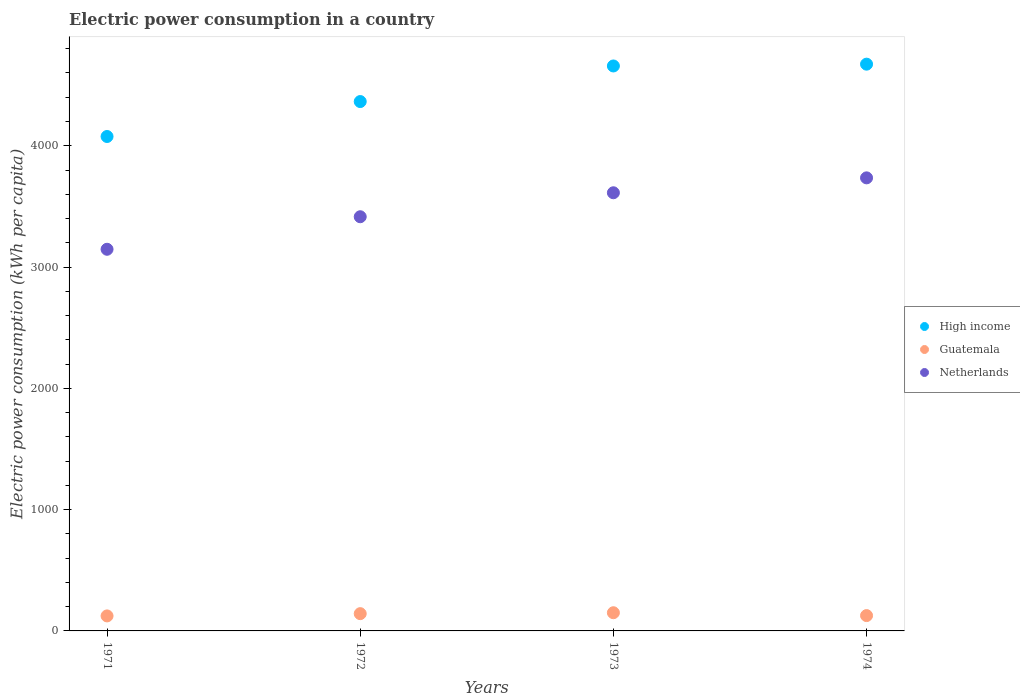How many different coloured dotlines are there?
Offer a very short reply. 3. Is the number of dotlines equal to the number of legend labels?
Provide a short and direct response. Yes. What is the electric power consumption in in Guatemala in 1973?
Keep it short and to the point. 149.95. Across all years, what is the maximum electric power consumption in in Netherlands?
Make the answer very short. 3735.24. Across all years, what is the minimum electric power consumption in in High income?
Keep it short and to the point. 4076.2. In which year was the electric power consumption in in High income maximum?
Your response must be concise. 1974. In which year was the electric power consumption in in High income minimum?
Make the answer very short. 1971. What is the total electric power consumption in in Guatemala in the graph?
Provide a succinct answer. 542.42. What is the difference between the electric power consumption in in Netherlands in 1972 and that in 1974?
Give a very brief answer. -320.55. What is the difference between the electric power consumption in in Guatemala in 1971 and the electric power consumption in in Netherlands in 1974?
Ensure brevity in your answer.  -3611.53. What is the average electric power consumption in in High income per year?
Provide a short and direct response. 4442.7. In the year 1974, what is the difference between the electric power consumption in in Guatemala and electric power consumption in in High income?
Make the answer very short. -4546.2. What is the ratio of the electric power consumption in in Netherlands in 1972 to that in 1974?
Offer a terse response. 0.91. What is the difference between the highest and the second highest electric power consumption in in Guatemala?
Your answer should be compact. 7.56. What is the difference between the highest and the lowest electric power consumption in in Guatemala?
Ensure brevity in your answer.  26.25. Is the sum of the electric power consumption in in Guatemala in 1971 and 1972 greater than the maximum electric power consumption in in Netherlands across all years?
Provide a succinct answer. No. Is it the case that in every year, the sum of the electric power consumption in in Netherlands and electric power consumption in in Guatemala  is greater than the electric power consumption in in High income?
Your answer should be compact. No. Does the electric power consumption in in High income monotonically increase over the years?
Provide a succinct answer. Yes. Is the electric power consumption in in Netherlands strictly greater than the electric power consumption in in High income over the years?
Provide a succinct answer. No. Is the electric power consumption in in Netherlands strictly less than the electric power consumption in in High income over the years?
Your answer should be very brief. Yes. What is the difference between two consecutive major ticks on the Y-axis?
Make the answer very short. 1000. Are the values on the major ticks of Y-axis written in scientific E-notation?
Ensure brevity in your answer.  No. Does the graph contain any zero values?
Ensure brevity in your answer.  No. Does the graph contain grids?
Make the answer very short. No. Where does the legend appear in the graph?
Offer a very short reply. Center right. How are the legend labels stacked?
Offer a terse response. Vertical. What is the title of the graph?
Make the answer very short. Electric power consumption in a country. Does "Cabo Verde" appear as one of the legend labels in the graph?
Provide a short and direct response. No. What is the label or title of the Y-axis?
Provide a succinct answer. Electric power consumption (kWh per capita). What is the Electric power consumption (kWh per capita) in High income in 1971?
Keep it short and to the point. 4076.2. What is the Electric power consumption (kWh per capita) of Guatemala in 1971?
Ensure brevity in your answer.  123.7. What is the Electric power consumption (kWh per capita) in Netherlands in 1971?
Offer a terse response. 3146.46. What is the Electric power consumption (kWh per capita) of High income in 1972?
Provide a short and direct response. 4364.31. What is the Electric power consumption (kWh per capita) of Guatemala in 1972?
Your answer should be very brief. 142.39. What is the Electric power consumption (kWh per capita) in Netherlands in 1972?
Offer a terse response. 3414.69. What is the Electric power consumption (kWh per capita) in High income in 1973?
Offer a terse response. 4657.71. What is the Electric power consumption (kWh per capita) of Guatemala in 1973?
Provide a short and direct response. 149.95. What is the Electric power consumption (kWh per capita) of Netherlands in 1973?
Give a very brief answer. 3612.31. What is the Electric power consumption (kWh per capita) of High income in 1974?
Keep it short and to the point. 4672.57. What is the Electric power consumption (kWh per capita) of Guatemala in 1974?
Keep it short and to the point. 126.38. What is the Electric power consumption (kWh per capita) in Netherlands in 1974?
Give a very brief answer. 3735.24. Across all years, what is the maximum Electric power consumption (kWh per capita) in High income?
Make the answer very short. 4672.57. Across all years, what is the maximum Electric power consumption (kWh per capita) of Guatemala?
Ensure brevity in your answer.  149.95. Across all years, what is the maximum Electric power consumption (kWh per capita) of Netherlands?
Ensure brevity in your answer.  3735.24. Across all years, what is the minimum Electric power consumption (kWh per capita) of High income?
Ensure brevity in your answer.  4076.2. Across all years, what is the minimum Electric power consumption (kWh per capita) in Guatemala?
Give a very brief answer. 123.7. Across all years, what is the minimum Electric power consumption (kWh per capita) of Netherlands?
Give a very brief answer. 3146.46. What is the total Electric power consumption (kWh per capita) of High income in the graph?
Provide a succinct answer. 1.78e+04. What is the total Electric power consumption (kWh per capita) in Guatemala in the graph?
Your answer should be very brief. 542.42. What is the total Electric power consumption (kWh per capita) in Netherlands in the graph?
Your answer should be very brief. 1.39e+04. What is the difference between the Electric power consumption (kWh per capita) of High income in 1971 and that in 1972?
Offer a terse response. -288.11. What is the difference between the Electric power consumption (kWh per capita) of Guatemala in 1971 and that in 1972?
Provide a short and direct response. -18.69. What is the difference between the Electric power consumption (kWh per capita) of Netherlands in 1971 and that in 1972?
Your response must be concise. -268.23. What is the difference between the Electric power consumption (kWh per capita) in High income in 1971 and that in 1973?
Provide a succinct answer. -581.5. What is the difference between the Electric power consumption (kWh per capita) of Guatemala in 1971 and that in 1973?
Ensure brevity in your answer.  -26.25. What is the difference between the Electric power consumption (kWh per capita) in Netherlands in 1971 and that in 1973?
Your response must be concise. -465.85. What is the difference between the Electric power consumption (kWh per capita) of High income in 1971 and that in 1974?
Provide a succinct answer. -596.37. What is the difference between the Electric power consumption (kWh per capita) of Guatemala in 1971 and that in 1974?
Provide a short and direct response. -2.67. What is the difference between the Electric power consumption (kWh per capita) of Netherlands in 1971 and that in 1974?
Provide a short and direct response. -588.77. What is the difference between the Electric power consumption (kWh per capita) of High income in 1972 and that in 1973?
Your response must be concise. -293.4. What is the difference between the Electric power consumption (kWh per capita) of Guatemala in 1972 and that in 1973?
Your response must be concise. -7.56. What is the difference between the Electric power consumption (kWh per capita) of Netherlands in 1972 and that in 1973?
Keep it short and to the point. -197.62. What is the difference between the Electric power consumption (kWh per capita) in High income in 1972 and that in 1974?
Provide a short and direct response. -308.27. What is the difference between the Electric power consumption (kWh per capita) of Guatemala in 1972 and that in 1974?
Offer a terse response. 16.01. What is the difference between the Electric power consumption (kWh per capita) of Netherlands in 1972 and that in 1974?
Keep it short and to the point. -320.55. What is the difference between the Electric power consumption (kWh per capita) of High income in 1973 and that in 1974?
Make the answer very short. -14.87. What is the difference between the Electric power consumption (kWh per capita) in Guatemala in 1973 and that in 1974?
Your response must be concise. 23.57. What is the difference between the Electric power consumption (kWh per capita) of Netherlands in 1973 and that in 1974?
Make the answer very short. -122.93. What is the difference between the Electric power consumption (kWh per capita) in High income in 1971 and the Electric power consumption (kWh per capita) in Guatemala in 1972?
Provide a succinct answer. 3933.81. What is the difference between the Electric power consumption (kWh per capita) of High income in 1971 and the Electric power consumption (kWh per capita) of Netherlands in 1972?
Keep it short and to the point. 661.51. What is the difference between the Electric power consumption (kWh per capita) in Guatemala in 1971 and the Electric power consumption (kWh per capita) in Netherlands in 1972?
Offer a very short reply. -3290.98. What is the difference between the Electric power consumption (kWh per capita) in High income in 1971 and the Electric power consumption (kWh per capita) in Guatemala in 1973?
Provide a short and direct response. 3926.25. What is the difference between the Electric power consumption (kWh per capita) in High income in 1971 and the Electric power consumption (kWh per capita) in Netherlands in 1973?
Keep it short and to the point. 463.89. What is the difference between the Electric power consumption (kWh per capita) of Guatemala in 1971 and the Electric power consumption (kWh per capita) of Netherlands in 1973?
Provide a short and direct response. -3488.61. What is the difference between the Electric power consumption (kWh per capita) in High income in 1971 and the Electric power consumption (kWh per capita) in Guatemala in 1974?
Your response must be concise. 3949.82. What is the difference between the Electric power consumption (kWh per capita) in High income in 1971 and the Electric power consumption (kWh per capita) in Netherlands in 1974?
Your answer should be very brief. 340.96. What is the difference between the Electric power consumption (kWh per capita) in Guatemala in 1971 and the Electric power consumption (kWh per capita) in Netherlands in 1974?
Your answer should be compact. -3611.53. What is the difference between the Electric power consumption (kWh per capita) in High income in 1972 and the Electric power consumption (kWh per capita) in Guatemala in 1973?
Provide a short and direct response. 4214.36. What is the difference between the Electric power consumption (kWh per capita) in High income in 1972 and the Electric power consumption (kWh per capita) in Netherlands in 1973?
Give a very brief answer. 752. What is the difference between the Electric power consumption (kWh per capita) in Guatemala in 1972 and the Electric power consumption (kWh per capita) in Netherlands in 1973?
Ensure brevity in your answer.  -3469.92. What is the difference between the Electric power consumption (kWh per capita) of High income in 1972 and the Electric power consumption (kWh per capita) of Guatemala in 1974?
Provide a short and direct response. 4237.93. What is the difference between the Electric power consumption (kWh per capita) in High income in 1972 and the Electric power consumption (kWh per capita) in Netherlands in 1974?
Provide a succinct answer. 629.07. What is the difference between the Electric power consumption (kWh per capita) in Guatemala in 1972 and the Electric power consumption (kWh per capita) in Netherlands in 1974?
Ensure brevity in your answer.  -3592.85. What is the difference between the Electric power consumption (kWh per capita) of High income in 1973 and the Electric power consumption (kWh per capita) of Guatemala in 1974?
Your response must be concise. 4531.33. What is the difference between the Electric power consumption (kWh per capita) of High income in 1973 and the Electric power consumption (kWh per capita) of Netherlands in 1974?
Your answer should be compact. 922.47. What is the difference between the Electric power consumption (kWh per capita) in Guatemala in 1973 and the Electric power consumption (kWh per capita) in Netherlands in 1974?
Your answer should be compact. -3585.29. What is the average Electric power consumption (kWh per capita) of High income per year?
Offer a terse response. 4442.7. What is the average Electric power consumption (kWh per capita) of Guatemala per year?
Provide a short and direct response. 135.61. What is the average Electric power consumption (kWh per capita) in Netherlands per year?
Your answer should be compact. 3477.18. In the year 1971, what is the difference between the Electric power consumption (kWh per capita) in High income and Electric power consumption (kWh per capita) in Guatemala?
Give a very brief answer. 3952.5. In the year 1971, what is the difference between the Electric power consumption (kWh per capita) in High income and Electric power consumption (kWh per capita) in Netherlands?
Your answer should be very brief. 929.74. In the year 1971, what is the difference between the Electric power consumption (kWh per capita) in Guatemala and Electric power consumption (kWh per capita) in Netherlands?
Offer a terse response. -3022.76. In the year 1972, what is the difference between the Electric power consumption (kWh per capita) in High income and Electric power consumption (kWh per capita) in Guatemala?
Offer a very short reply. 4221.92. In the year 1972, what is the difference between the Electric power consumption (kWh per capita) of High income and Electric power consumption (kWh per capita) of Netherlands?
Provide a short and direct response. 949.62. In the year 1972, what is the difference between the Electric power consumption (kWh per capita) of Guatemala and Electric power consumption (kWh per capita) of Netherlands?
Offer a terse response. -3272.3. In the year 1973, what is the difference between the Electric power consumption (kWh per capita) of High income and Electric power consumption (kWh per capita) of Guatemala?
Your answer should be very brief. 4507.76. In the year 1973, what is the difference between the Electric power consumption (kWh per capita) in High income and Electric power consumption (kWh per capita) in Netherlands?
Ensure brevity in your answer.  1045.4. In the year 1973, what is the difference between the Electric power consumption (kWh per capita) in Guatemala and Electric power consumption (kWh per capita) in Netherlands?
Keep it short and to the point. -3462.36. In the year 1974, what is the difference between the Electric power consumption (kWh per capita) in High income and Electric power consumption (kWh per capita) in Guatemala?
Ensure brevity in your answer.  4546.2. In the year 1974, what is the difference between the Electric power consumption (kWh per capita) of High income and Electric power consumption (kWh per capita) of Netherlands?
Provide a succinct answer. 937.34. In the year 1974, what is the difference between the Electric power consumption (kWh per capita) of Guatemala and Electric power consumption (kWh per capita) of Netherlands?
Offer a very short reply. -3608.86. What is the ratio of the Electric power consumption (kWh per capita) of High income in 1971 to that in 1972?
Offer a very short reply. 0.93. What is the ratio of the Electric power consumption (kWh per capita) in Guatemala in 1971 to that in 1972?
Keep it short and to the point. 0.87. What is the ratio of the Electric power consumption (kWh per capita) in Netherlands in 1971 to that in 1972?
Ensure brevity in your answer.  0.92. What is the ratio of the Electric power consumption (kWh per capita) in High income in 1971 to that in 1973?
Keep it short and to the point. 0.88. What is the ratio of the Electric power consumption (kWh per capita) in Guatemala in 1971 to that in 1973?
Your answer should be very brief. 0.82. What is the ratio of the Electric power consumption (kWh per capita) of Netherlands in 1971 to that in 1973?
Your answer should be very brief. 0.87. What is the ratio of the Electric power consumption (kWh per capita) of High income in 1971 to that in 1974?
Provide a short and direct response. 0.87. What is the ratio of the Electric power consumption (kWh per capita) of Guatemala in 1971 to that in 1974?
Your response must be concise. 0.98. What is the ratio of the Electric power consumption (kWh per capita) of Netherlands in 1971 to that in 1974?
Give a very brief answer. 0.84. What is the ratio of the Electric power consumption (kWh per capita) in High income in 1972 to that in 1973?
Your answer should be compact. 0.94. What is the ratio of the Electric power consumption (kWh per capita) of Guatemala in 1972 to that in 1973?
Make the answer very short. 0.95. What is the ratio of the Electric power consumption (kWh per capita) in Netherlands in 1972 to that in 1973?
Provide a short and direct response. 0.95. What is the ratio of the Electric power consumption (kWh per capita) of High income in 1972 to that in 1974?
Give a very brief answer. 0.93. What is the ratio of the Electric power consumption (kWh per capita) of Guatemala in 1972 to that in 1974?
Keep it short and to the point. 1.13. What is the ratio of the Electric power consumption (kWh per capita) of Netherlands in 1972 to that in 1974?
Offer a very short reply. 0.91. What is the ratio of the Electric power consumption (kWh per capita) in High income in 1973 to that in 1974?
Your answer should be compact. 1. What is the ratio of the Electric power consumption (kWh per capita) of Guatemala in 1973 to that in 1974?
Offer a terse response. 1.19. What is the ratio of the Electric power consumption (kWh per capita) of Netherlands in 1973 to that in 1974?
Keep it short and to the point. 0.97. What is the difference between the highest and the second highest Electric power consumption (kWh per capita) of High income?
Your answer should be compact. 14.87. What is the difference between the highest and the second highest Electric power consumption (kWh per capita) in Guatemala?
Give a very brief answer. 7.56. What is the difference between the highest and the second highest Electric power consumption (kWh per capita) in Netherlands?
Provide a succinct answer. 122.93. What is the difference between the highest and the lowest Electric power consumption (kWh per capita) of High income?
Provide a succinct answer. 596.37. What is the difference between the highest and the lowest Electric power consumption (kWh per capita) in Guatemala?
Your answer should be very brief. 26.25. What is the difference between the highest and the lowest Electric power consumption (kWh per capita) of Netherlands?
Provide a succinct answer. 588.77. 